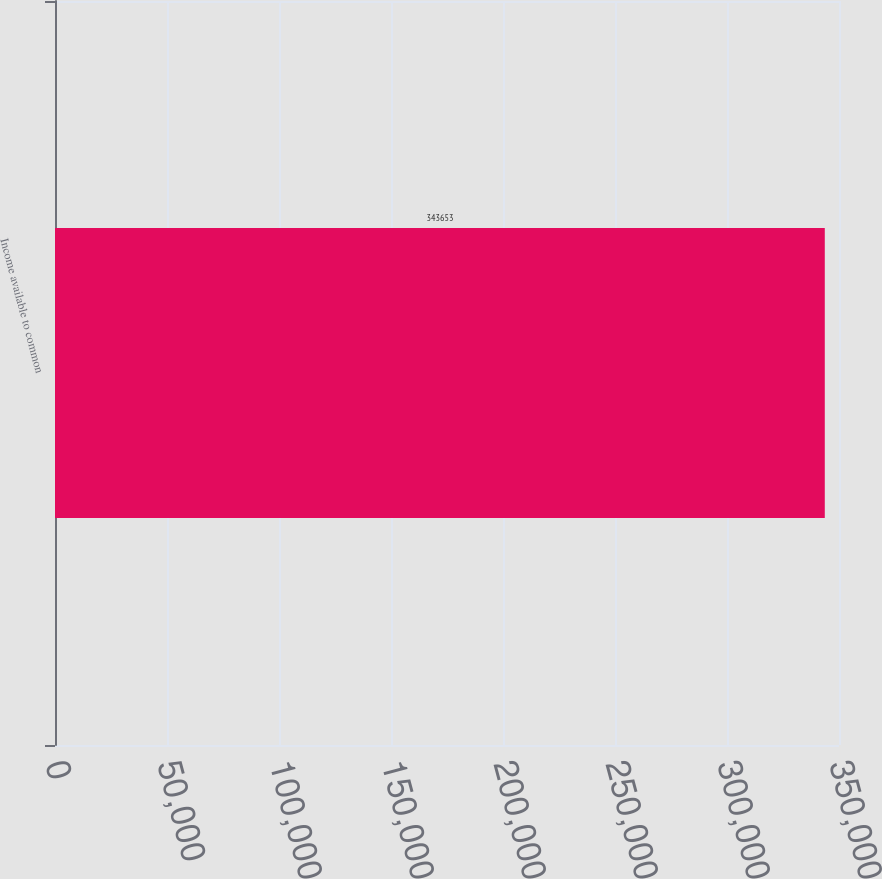<chart> <loc_0><loc_0><loc_500><loc_500><bar_chart><fcel>Income available to common<nl><fcel>343653<nl></chart> 